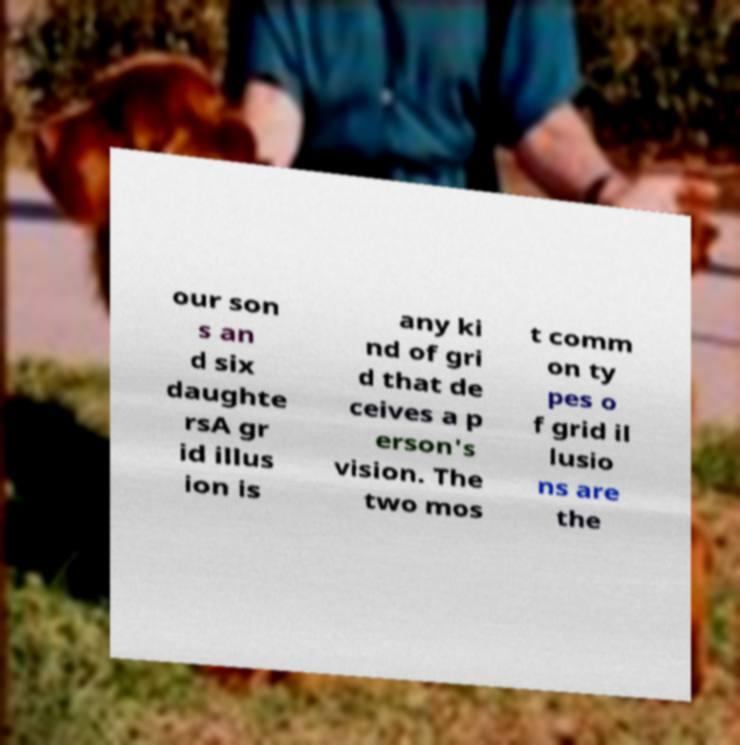Please read and relay the text visible in this image. What does it say? our son s an d six daughte rsA gr id illus ion is any ki nd of gri d that de ceives a p erson's vision. The two mos t comm on ty pes o f grid il lusio ns are the 